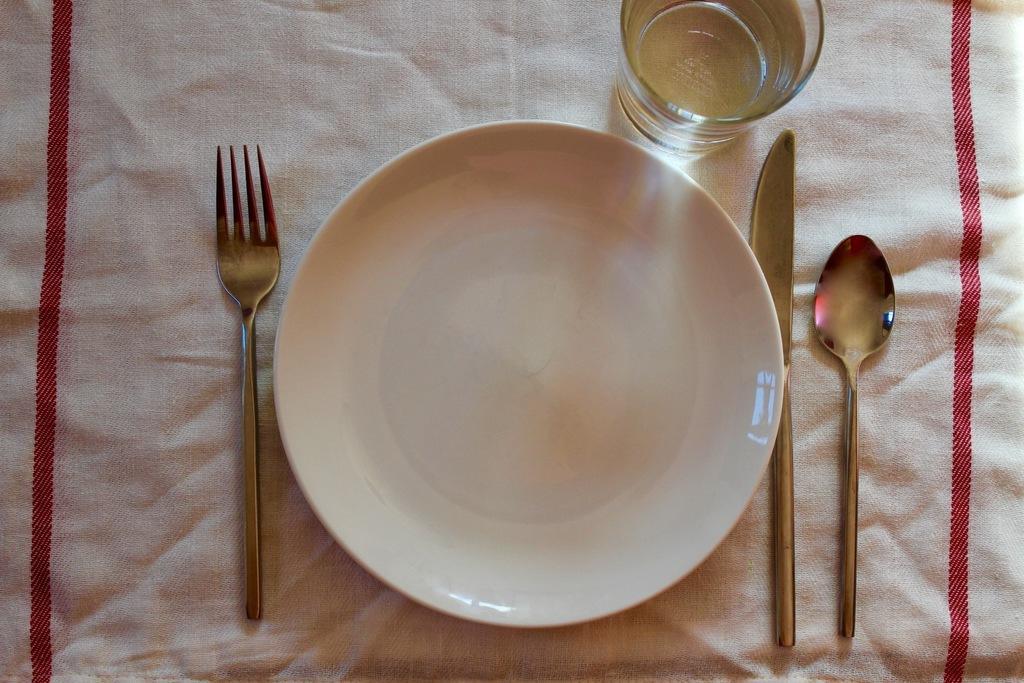Could you give a brief overview of what you see in this image? In the image there is an empty plate, a fork, spoon, knife and a glass filled with some water, under the plate there is a cloth. 